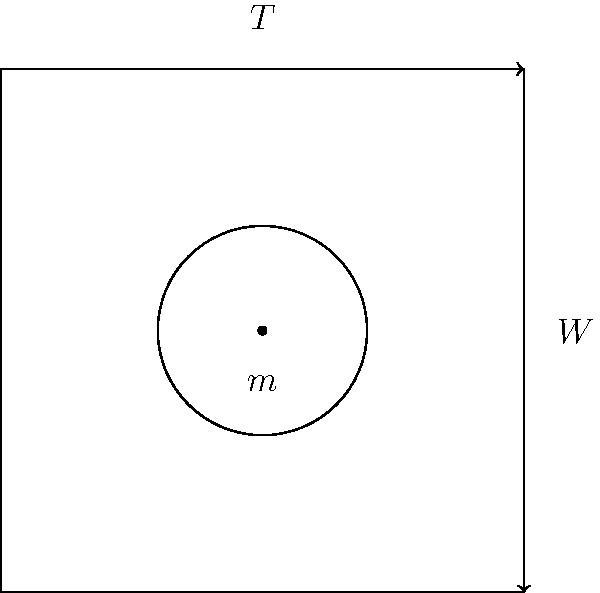A senior-friendly pulley system is designed for gentle arm exercises. The system consists of a weight $m$ suspended by a rope that passes over a frictionless pulley. If the tension in the rope is $T$ and the weight of the mass is $W$, what is the relationship between $T$ and $W$ when the system is in equilibrium? To understand the relationship between tension $T$ and weight $W$, let's follow these steps:

1. In equilibrium, the sum of forces acting on the mass must be zero.

2. There are two forces acting on the mass:
   a) The weight $W$ acting downward
   b) The tension $T$ in the rope acting upward

3. For equilibrium:
   $\sum F = 0$
   $T - W = 0$

4. Rearranging the equation:
   $T = W$

5. We know that $W = mg$, where $m$ is the mass and $g$ is the acceleration due to gravity (9.8 m/s²).

6. Therefore, we can also express the tension as:
   $T = mg$

This relationship shows that the tension in the rope is equal to the weight of the suspended mass when the system is in equilibrium. This is why the effort required to hold the weight steady is equal to the weight itself, making it suitable for controlled, low-impact exercises for seniors.
Answer: $T = W$ 